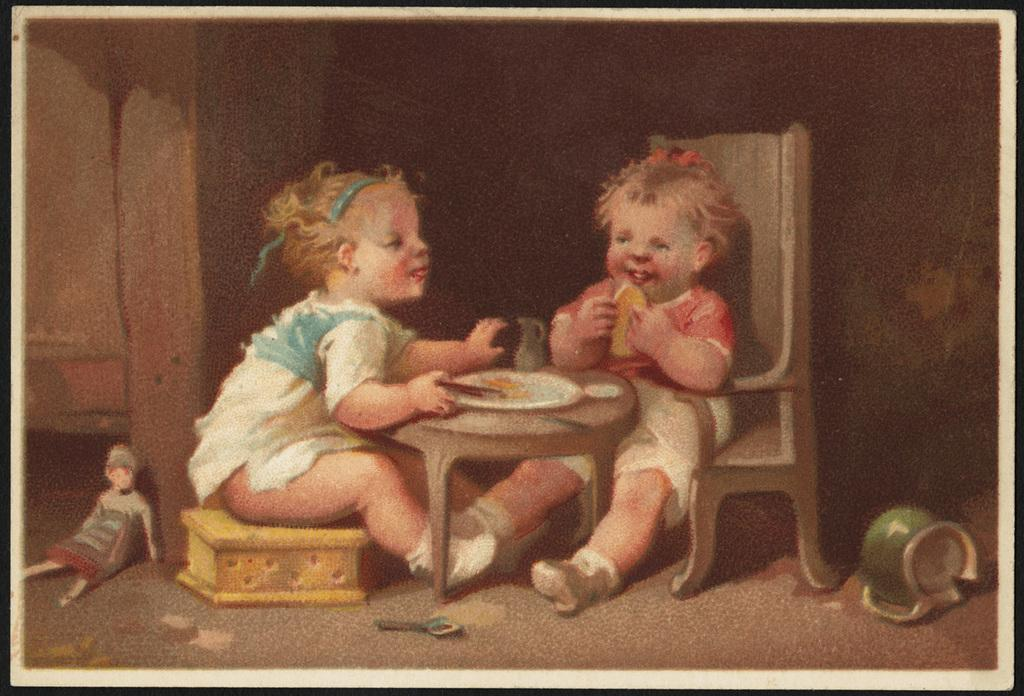How many kids are present in the image? There are two kids in the frame. What are the kids doing in the image? The kids are sitting and eating. What is the setting for the kids in the image? There is a table in the frame. What items are on the table? There is a plate and a spoon on the table. Are there any toys visible in the image? Yes, there are dolls in the frame. What type of twig is being used as a utensil by the kids in the image? There is no twig present in the image; the kids are using a spoon to eat. How many chickens are visible in the image? There are no chickens present in the image. 